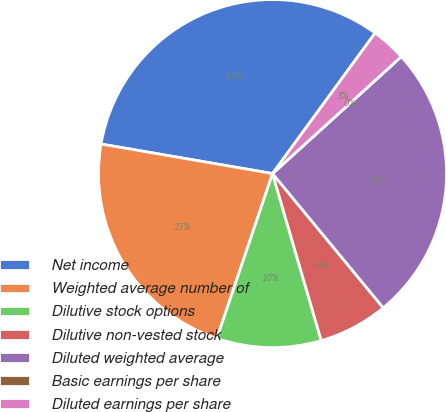Convert chart. <chart><loc_0><loc_0><loc_500><loc_500><pie_chart><fcel>Net income<fcel>Weighted average number of<fcel>Dilutive stock options<fcel>Dilutive non-vested stock<fcel>Diluted weighted average<fcel>Basic earnings per share<fcel>Diluted earnings per share<nl><fcel>32.32%<fcel>22.53%<fcel>9.7%<fcel>6.46%<fcel>25.76%<fcel>0.0%<fcel>3.23%<nl></chart> 